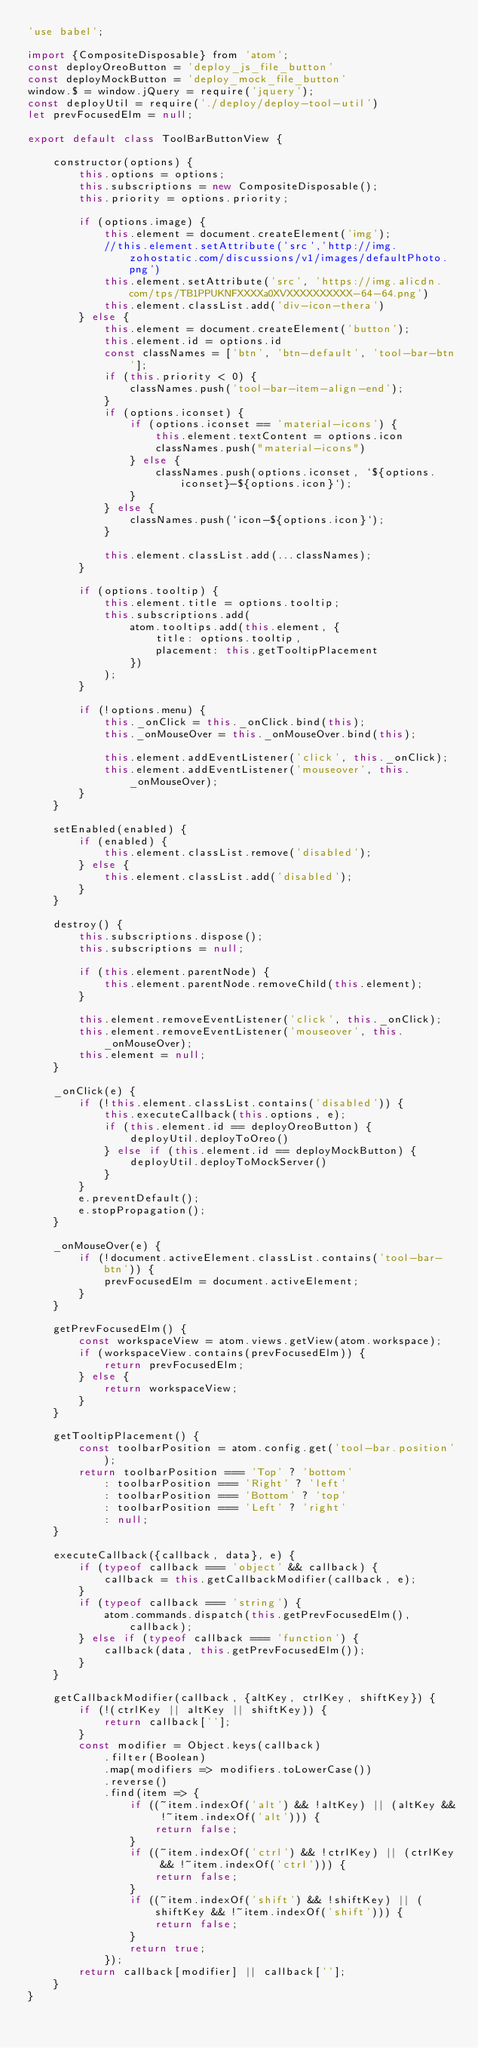Convert code to text. <code><loc_0><loc_0><loc_500><loc_500><_JavaScript_>'use babel';

import {CompositeDisposable} from 'atom';
const deployOreoButton = 'deploy_js_file_button'
const deployMockButton = 'deploy_mock_file_button'
window.$ = window.jQuery = require('jquery');
const deployUtil = require('./deploy/deploy-tool-util')
let prevFocusedElm = null;

export default class ToolBarButtonView {

    constructor(options) {
        this.options = options;
        this.subscriptions = new CompositeDisposable();
        this.priority = options.priority;

        if (options.image) {
            this.element = document.createElement('img');
            //this.element.setAttribute('src','http://img.zohostatic.com/discussions/v1/images/defaultPhoto.png')
            this.element.setAttribute('src', 'https://img.alicdn.com/tps/TB1PPUKNFXXXXa0XVXXXXXXXXXX-64-64.png')
            this.element.classList.add('div-icon-thera')
        } else {
            this.element = document.createElement('button');
            this.element.id = options.id
            const classNames = ['btn', 'btn-default', 'tool-bar-btn'];
            if (this.priority < 0) {
                classNames.push('tool-bar-item-align-end');
            }
            if (options.iconset) {
                if (options.iconset == 'material-icons') {
                    this.element.textContent = options.icon
                    classNames.push("material-icons")
                } else {
                    classNames.push(options.iconset, `${options.iconset}-${options.icon}`);
                }
            } else {
                classNames.push(`icon-${options.icon}`);
            }

            this.element.classList.add(...classNames);
        }

        if (options.tooltip) {
            this.element.title = options.tooltip;
            this.subscriptions.add(
                atom.tooltips.add(this.element, {
                    title: options.tooltip,
                    placement: this.getTooltipPlacement
                })
            );
        }

        if (!options.menu) {
            this._onClick = this._onClick.bind(this);
            this._onMouseOver = this._onMouseOver.bind(this);

            this.element.addEventListener('click', this._onClick);
            this.element.addEventListener('mouseover', this._onMouseOver);
        }
    }

    setEnabled(enabled) {
        if (enabled) {
            this.element.classList.remove('disabled');
        } else {
            this.element.classList.add('disabled');
        }
    }

    destroy() {
        this.subscriptions.dispose();
        this.subscriptions = null;

        if (this.element.parentNode) {
            this.element.parentNode.removeChild(this.element);
        }

        this.element.removeEventListener('click', this._onClick);
        this.element.removeEventListener('mouseover', this._onMouseOver);
        this.element = null;
    }

    _onClick(e) {
        if (!this.element.classList.contains('disabled')) {
            this.executeCallback(this.options, e);
            if (this.element.id == deployOreoButton) {
                deployUtil.deployToOreo()
            } else if (this.element.id == deployMockButton) {
                deployUtil.deployToMockServer()
            }
        }
        e.preventDefault();
        e.stopPropagation();
    }

    _onMouseOver(e) {
        if (!document.activeElement.classList.contains('tool-bar-btn')) {
            prevFocusedElm = document.activeElement;
        }
    }

    getPrevFocusedElm() {
        const workspaceView = atom.views.getView(atom.workspace);
        if (workspaceView.contains(prevFocusedElm)) {
            return prevFocusedElm;
        } else {
            return workspaceView;
        }
    }

    getTooltipPlacement() {
        const toolbarPosition = atom.config.get('tool-bar.position');
        return toolbarPosition === 'Top' ? 'bottom'
            : toolbarPosition === 'Right' ? 'left'
            : toolbarPosition === 'Bottom' ? 'top'
            : toolbarPosition === 'Left' ? 'right'
            : null;
    }

    executeCallback({callback, data}, e) {
        if (typeof callback === 'object' && callback) {
            callback = this.getCallbackModifier(callback, e);
        }
        if (typeof callback === 'string') {
            atom.commands.dispatch(this.getPrevFocusedElm(), callback);
        } else if (typeof callback === 'function') {
            callback(data, this.getPrevFocusedElm());
        }
    }

    getCallbackModifier(callback, {altKey, ctrlKey, shiftKey}) {
        if (!(ctrlKey || altKey || shiftKey)) {
            return callback[''];
        }
        const modifier = Object.keys(callback)
            .filter(Boolean)
            .map(modifiers => modifiers.toLowerCase())
            .reverse()
            .find(item => {
                if ((~item.indexOf('alt') && !altKey) || (altKey && !~item.indexOf('alt'))) {
                    return false;
                }
                if ((~item.indexOf('ctrl') && !ctrlKey) || (ctrlKey && !~item.indexOf('ctrl'))) {
                    return false;
                }
                if ((~item.indexOf('shift') && !shiftKey) || (shiftKey && !~item.indexOf('shift'))) {
                    return false;
                }
                return true;
            });
        return callback[modifier] || callback[''];
    }
}
</code> 